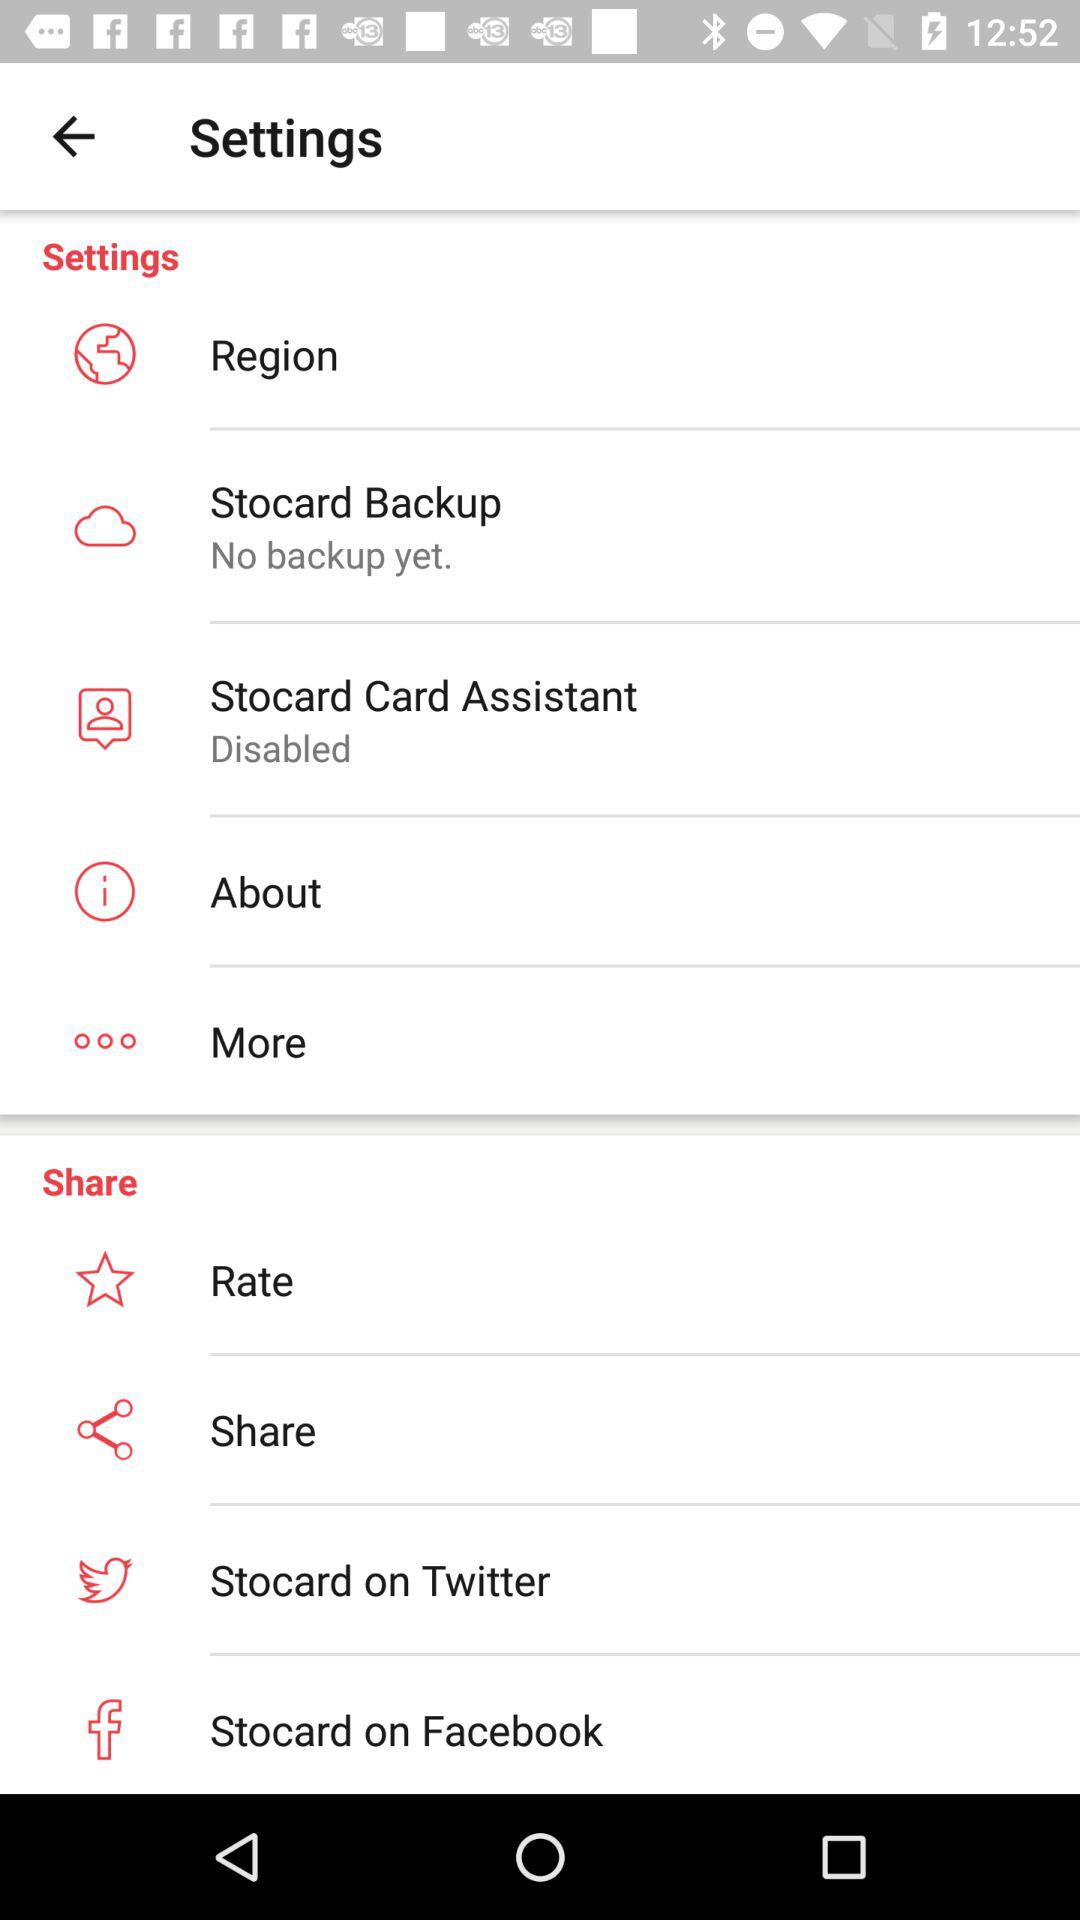What is the setting for the stocard card assistant? The setting for the Stocard card assistant is disabled. 